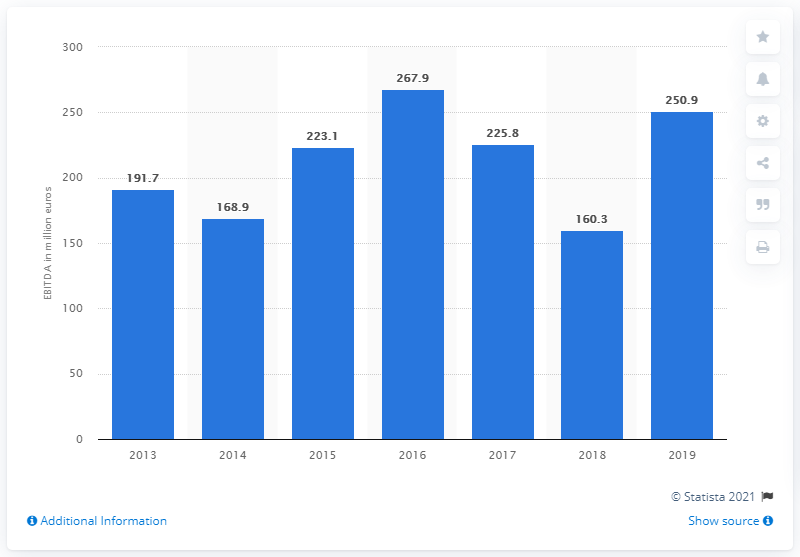Identify some key points in this picture. In 2016, Mapei's EBITDA was 267.9. The EBITDA of Mapei in 2013 was 191.7. In 2019, Mapei's EBITDA was 250.9 million. 